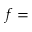<formula> <loc_0><loc_0><loc_500><loc_500>f =</formula> 